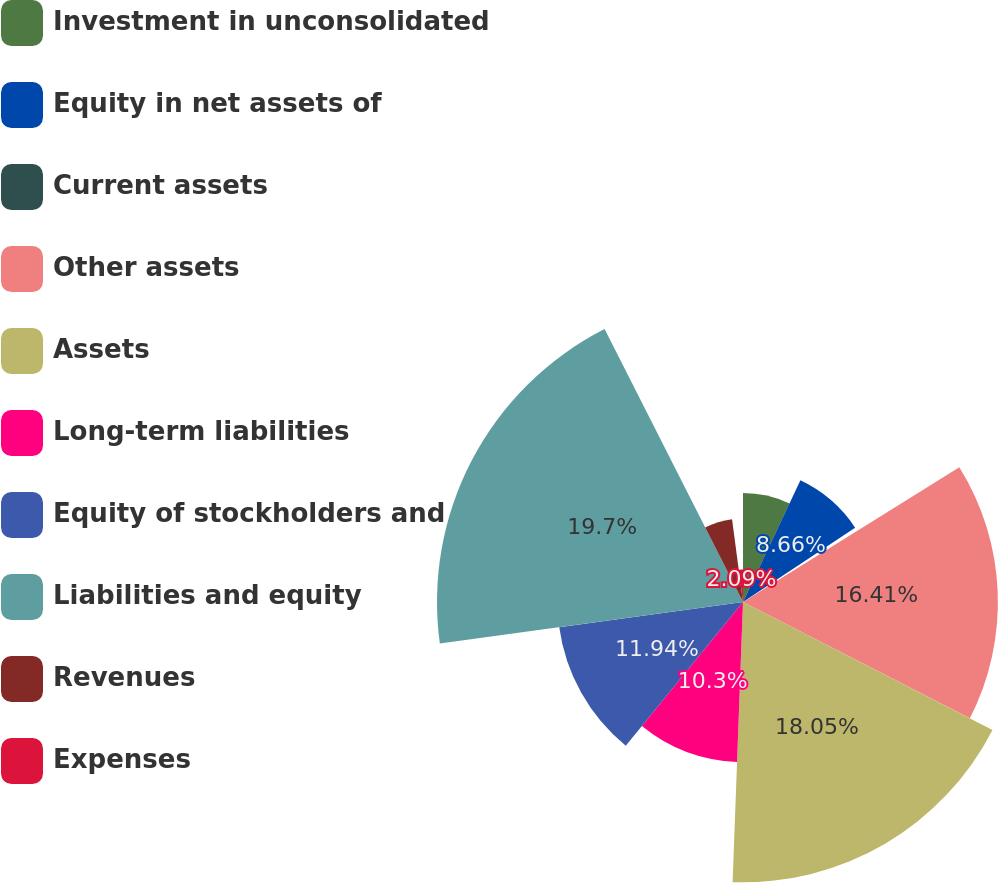Convert chart. <chart><loc_0><loc_0><loc_500><loc_500><pie_chart><fcel>Investment in unconsolidated<fcel>Equity in net assets of<fcel>Current assets<fcel>Other assets<fcel>Assets<fcel>Long-term liabilities<fcel>Equity of stockholders and<fcel>Liabilities and equity<fcel>Revenues<fcel>Expenses<nl><fcel>7.02%<fcel>8.66%<fcel>0.45%<fcel>16.41%<fcel>18.05%<fcel>10.3%<fcel>11.94%<fcel>19.7%<fcel>5.38%<fcel>2.09%<nl></chart> 